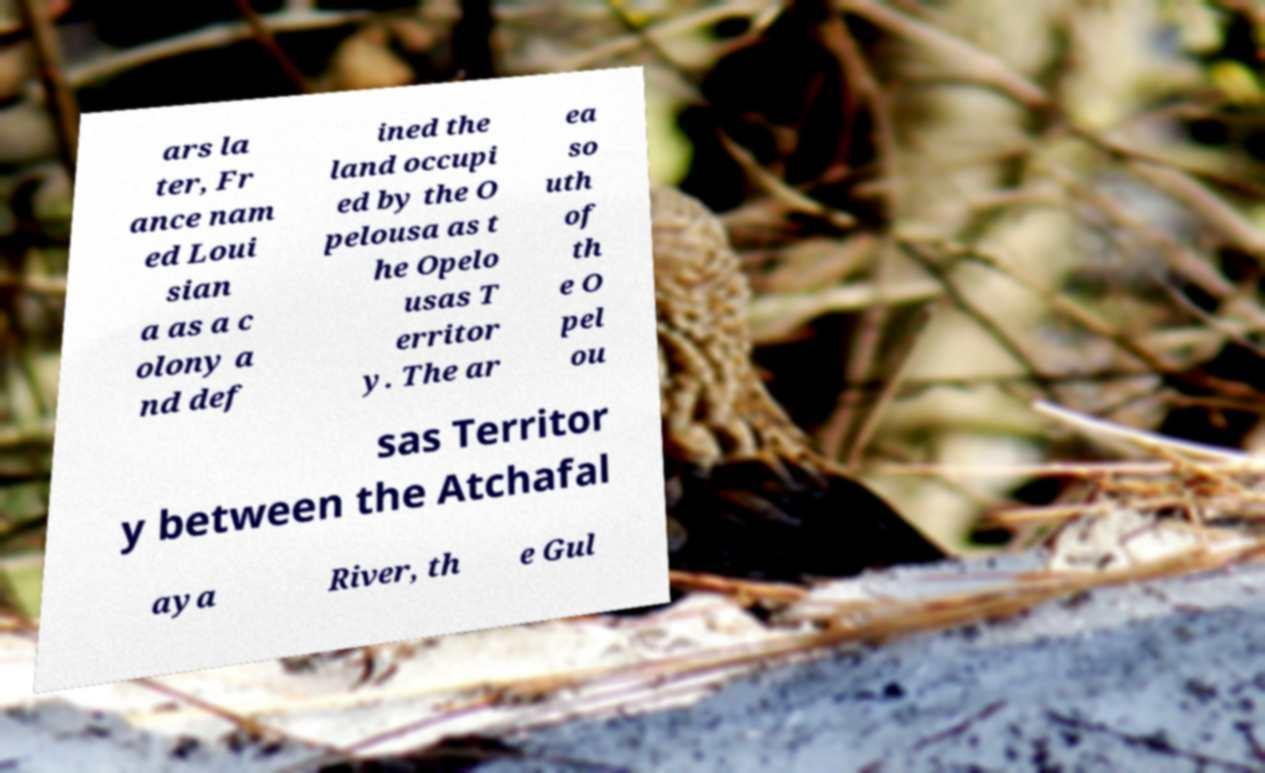Please identify and transcribe the text found in this image. ars la ter, Fr ance nam ed Loui sian a as a c olony a nd def ined the land occupi ed by the O pelousa as t he Opelo usas T erritor y. The ar ea so uth of th e O pel ou sas Territor y between the Atchafal aya River, th e Gul 